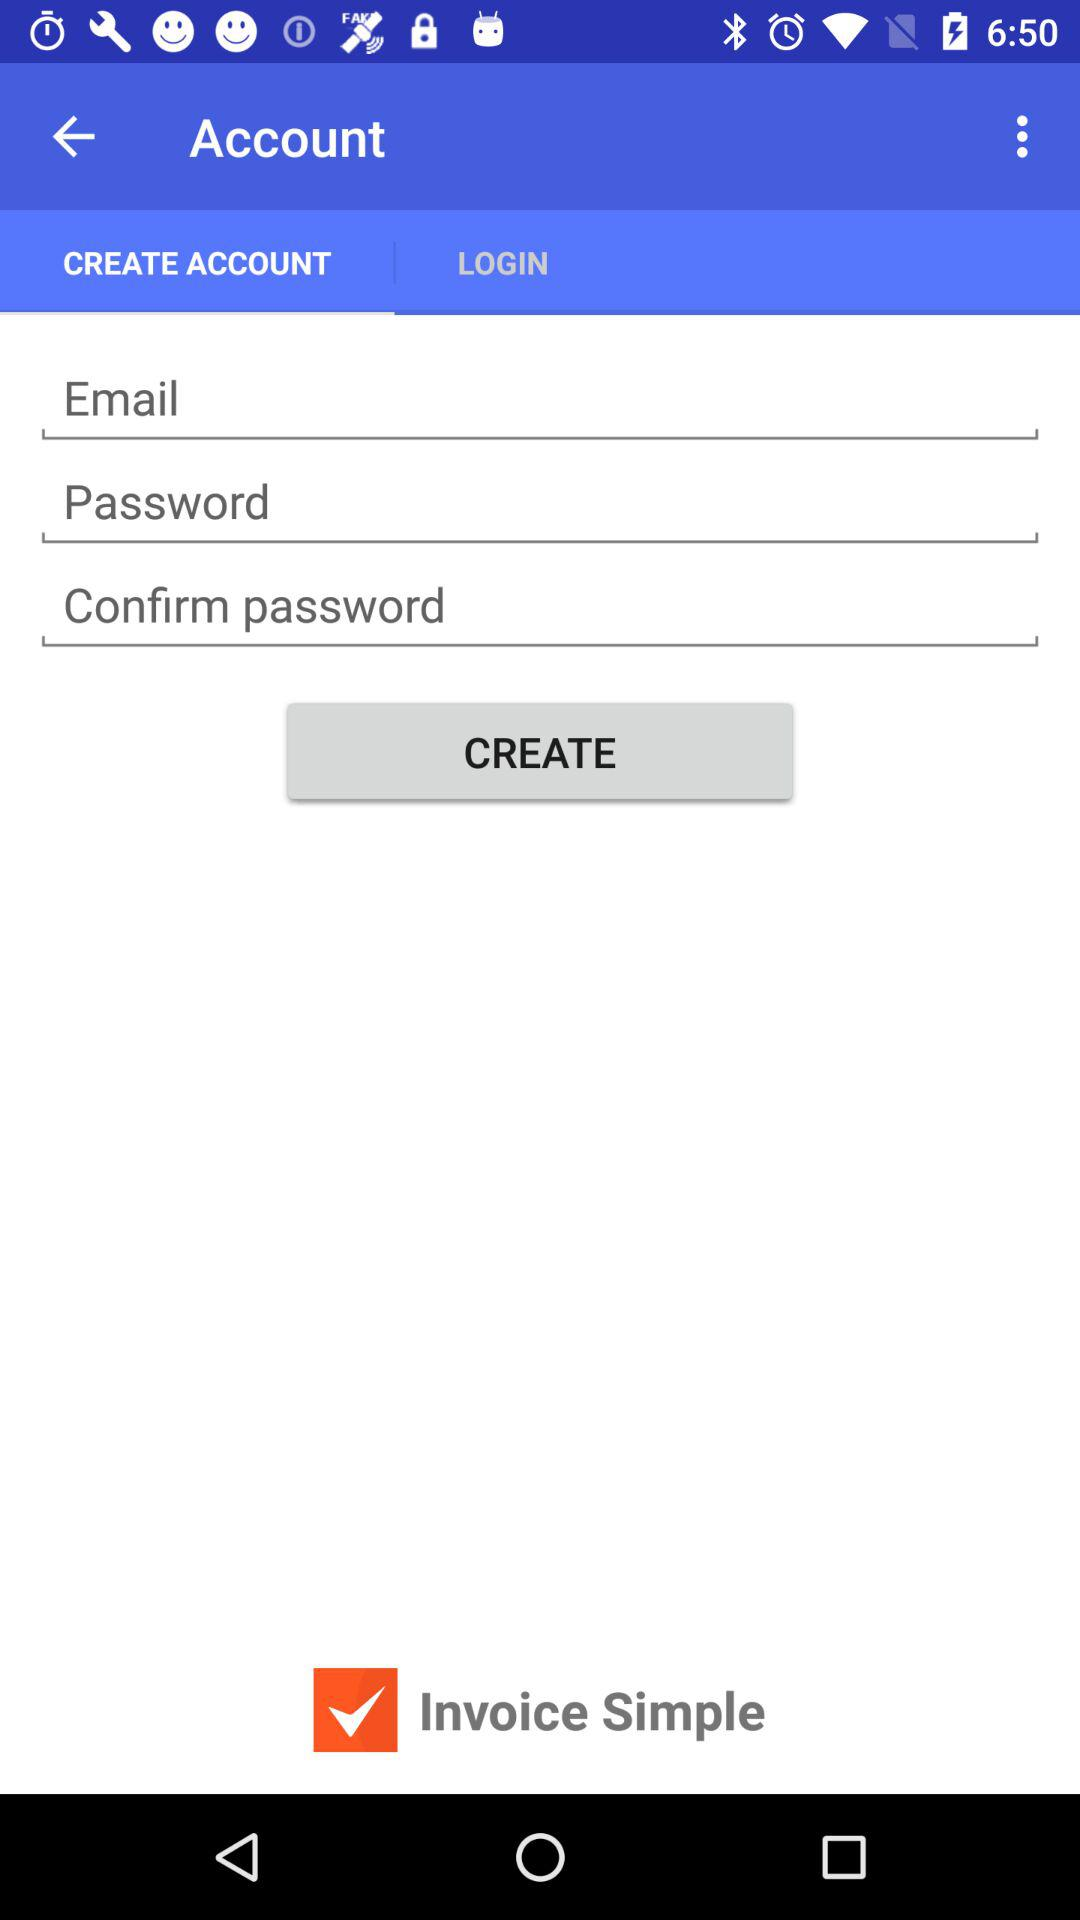What is the status of "Invoice Simple"? The status is on. 